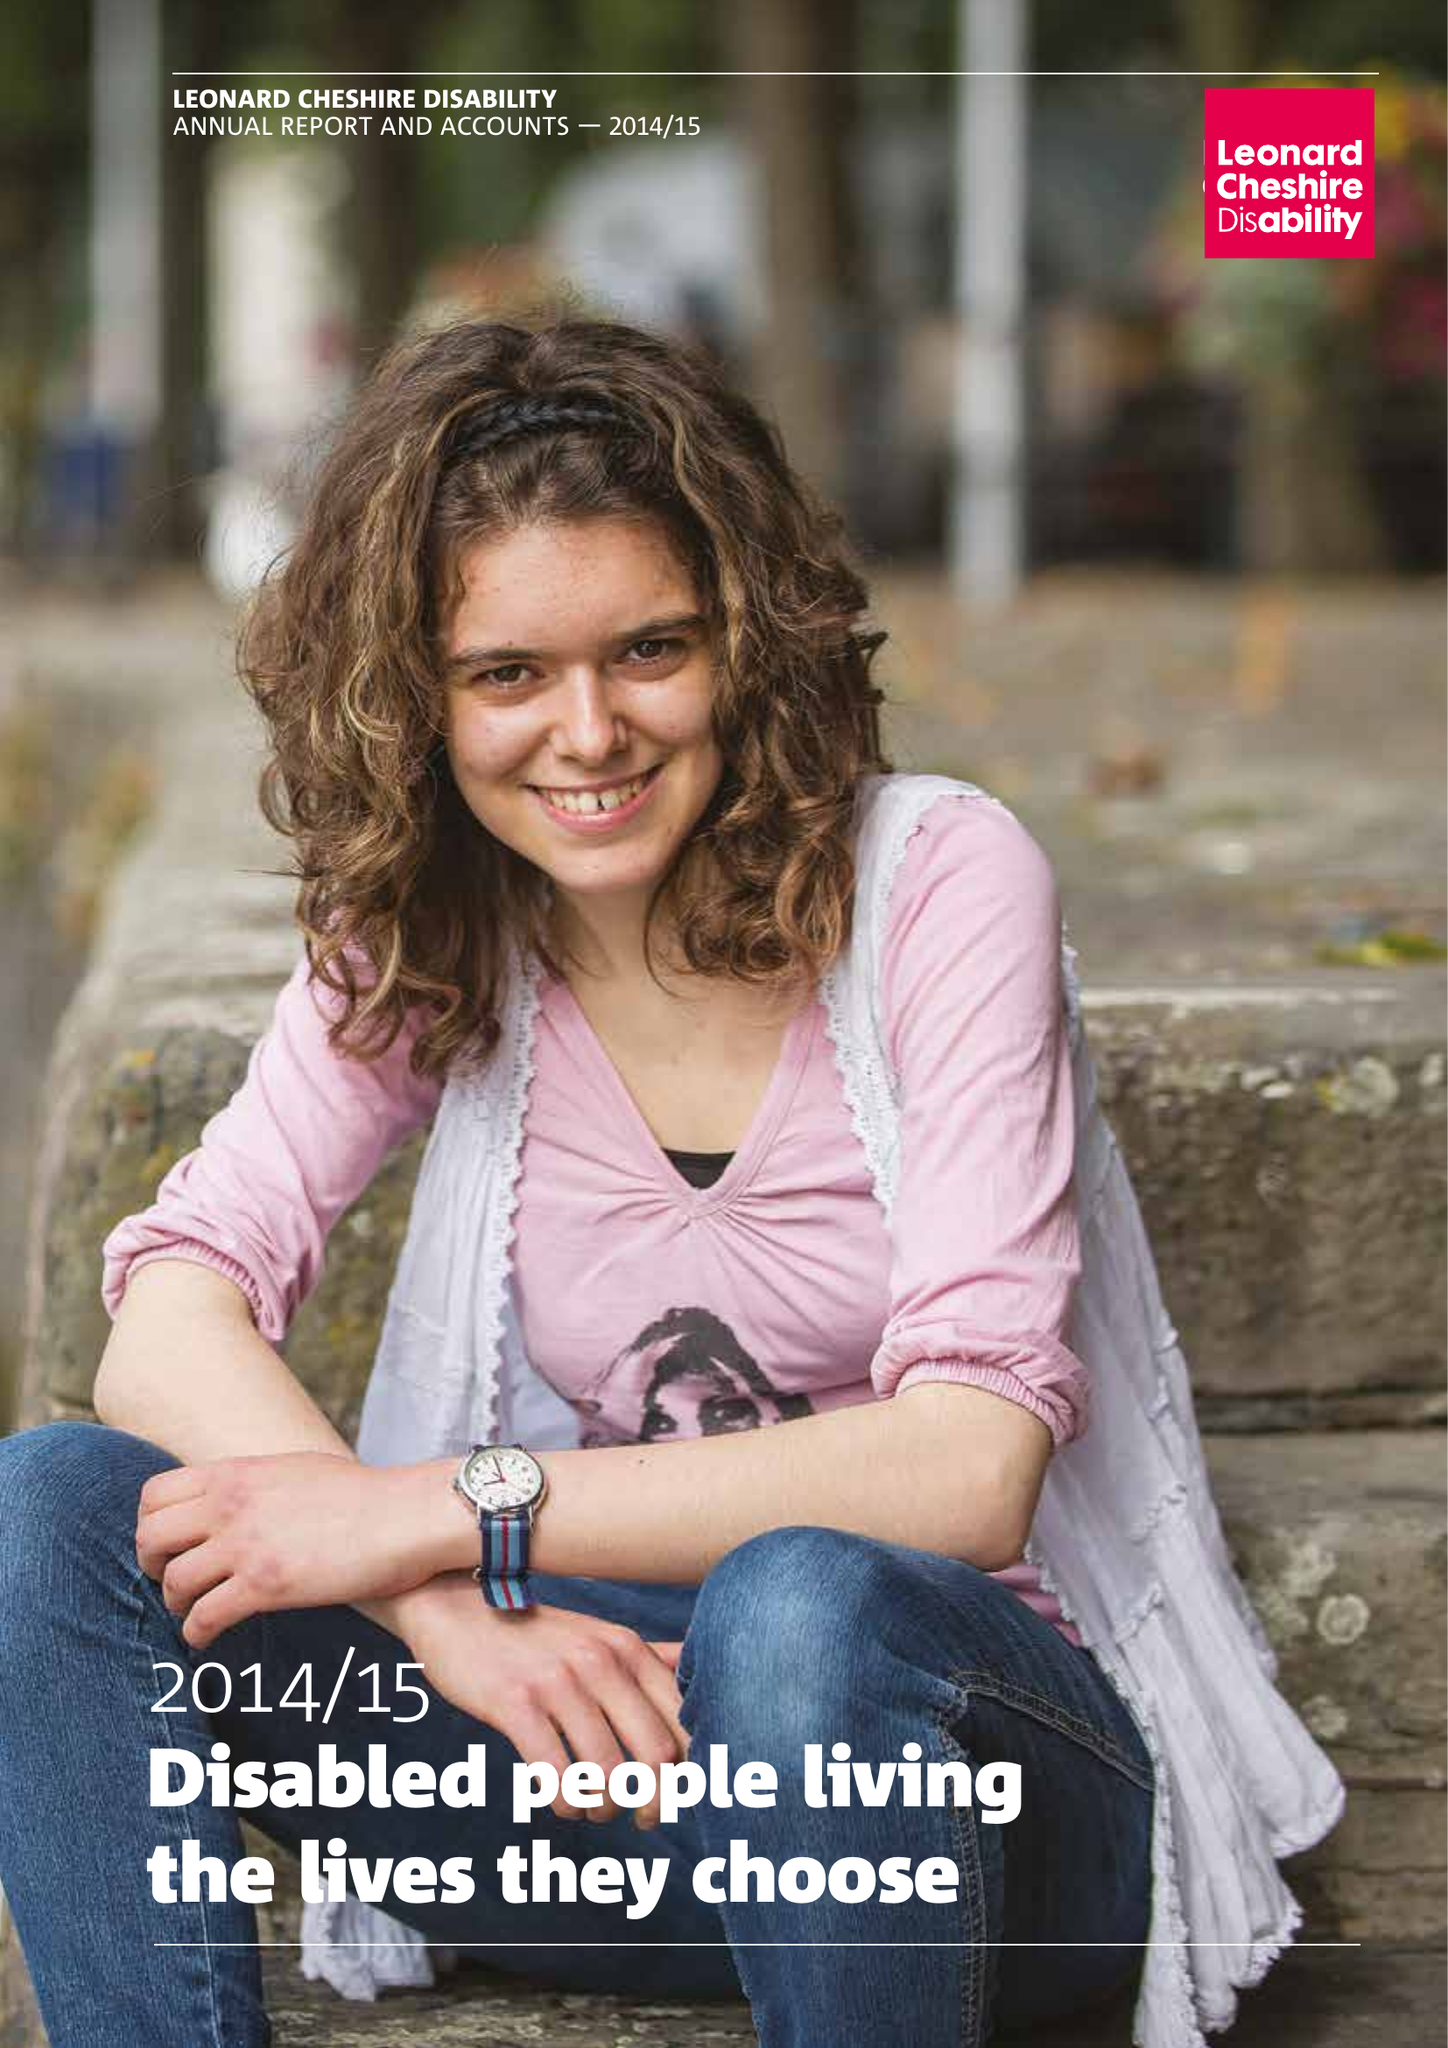What is the value for the address__postcode?
Answer the question using a single word or phrase. SW8 1RL 